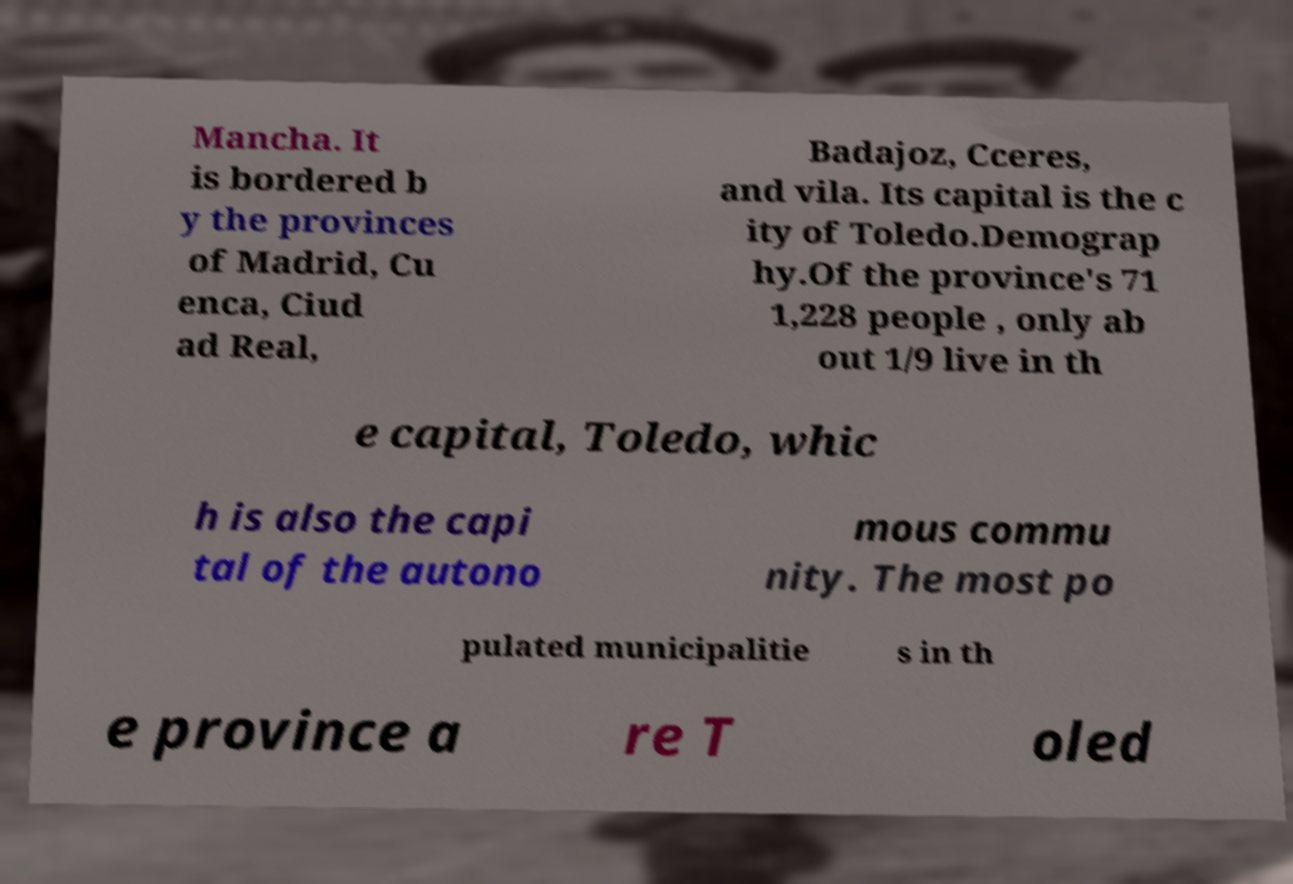I need the written content from this picture converted into text. Can you do that? Mancha. It is bordered b y the provinces of Madrid, Cu enca, Ciud ad Real, Badajoz, Cceres, and vila. Its capital is the c ity of Toledo.Demograp hy.Of the province's 71 1,228 people , only ab out 1/9 live in th e capital, Toledo, whic h is also the capi tal of the autono mous commu nity. The most po pulated municipalitie s in th e province a re T oled 